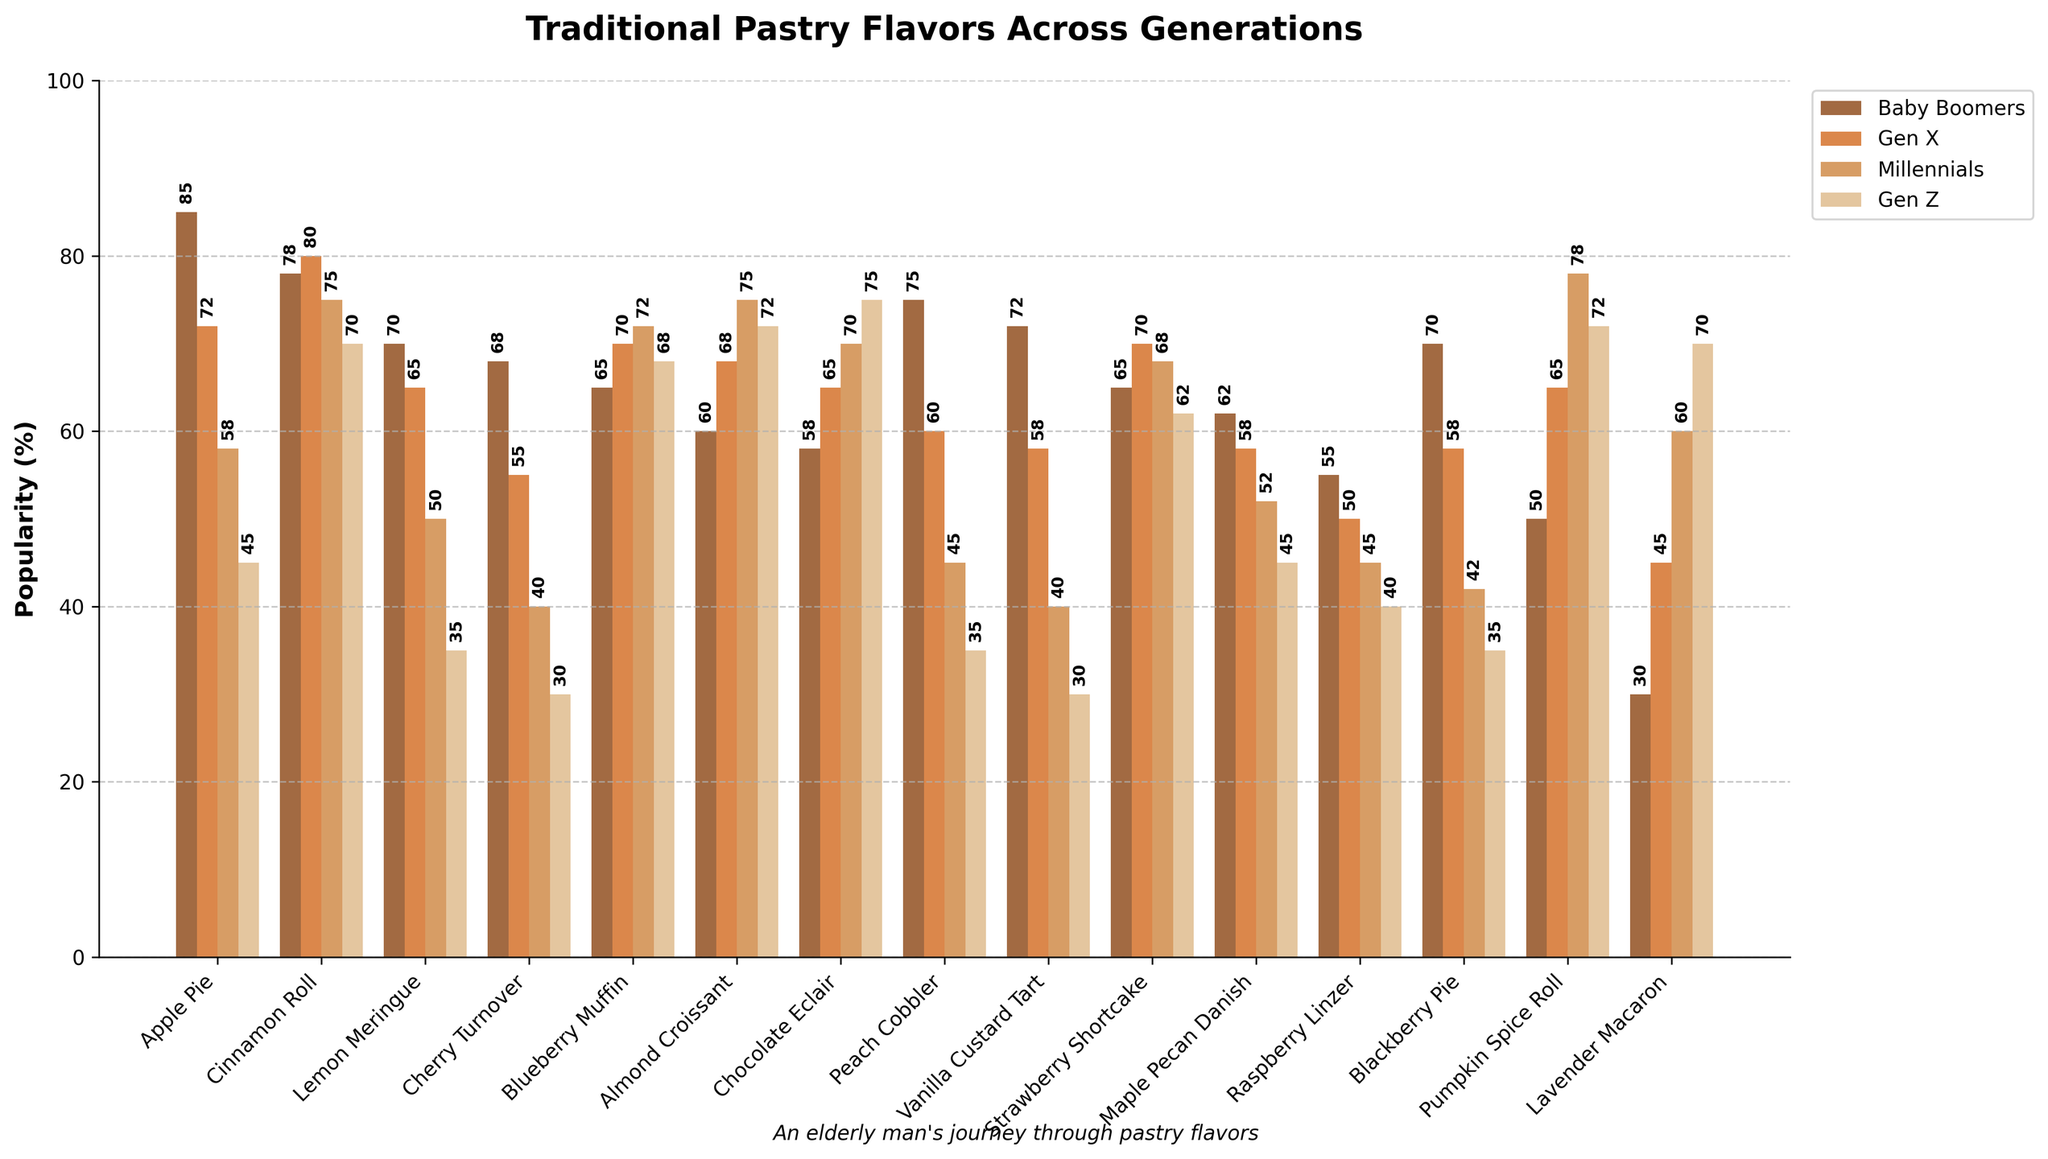Which traditional pastry flavor is the most popular among Baby Boomers? Look at the bars corresponding to Baby Boomers and compare their heights to find the tallest one. The Apple Pie bar has the highest value at 85%.
Answer: Apple Pie Which generation favors Pumpkin Spice Roll the most? Observe the bars corresponding to each generation for Pumpkin Spice Roll. The bar for Gen Z is the tallest, indicating the highest preference among the generations.
Answer: Gen Z What's the difference in popularity of Cinnamon Roll between Baby Boomers and Gen Z? Locate the bars for Cinnamon Roll for both Baby Boomers and Gen Z. Baby Boomers show 78% and Gen Z 70%. Calculate the difference: 78 - 70 = 8%.
Answer: 8% Which generation has the least preference for Raspberry Linzer? Compare the values of Raspberry Linzer for all generations. Gen Z has the lowest bar with 40%.
Answer: Gen Z How does the popularity of Almond Croissant change from Baby Boomers to Millennials? Find the popularity percentages of Almond Croissant for Baby Boomers (60%), Gen X (68%), and Millennials (75%). Note the increasing trend: 60% to 68% to 75%.
Answer: Increases What's the average popularity of Chocolate Eclair across all generations? Sum the popularity percentages of Chocolate Eclair for all generations: 58 + 65 + 70 + 75 = 268. Divide by the number of generations, 268 / 4 = 67%.
Answer: 67% Which flavor shows the most significant generational shift in preference from Baby Boomers to Gen Z? Compare the differences in percentages between Baby Boomers to Gen Z for all flavors. Pumpkin Spice Roll increases from 50% to 72%, a difference of 22%, the largest shift observed.
Answer: Pumpkin Spice Roll Compare the popularity of Blueberry Muffin between Gen X and Millennials. Look at the bars for Blueberry Muffin for Gen X (70%) and Millennials (72%). The numbers are close but Millennials show a slightly higher preference by 2%.
Answer: Millennials What is the second most popular flavor among Gen X? Look at the bars for all flavors in the Gen X category. Cinnamon Roll (80%) is the highest, followed by Blueberry Muffin (70%) and Strawberry Shortcake (70%). The second highest shared equally are Blueberry Muffin and Strawberry Shortcake at 70%.
Answer: Blueberry Muffin, Strawberry Shortcake Which flavor has the least difference in popularity across all generations? Assess the differences in popularity for each flavor by finding the minimum and maximum values for each one. Cinnamon Roll has values of 78%, 80%, 75%, and 70%, showing a range of 10%, the smallest variation.
Answer: Cinnamon Roll 